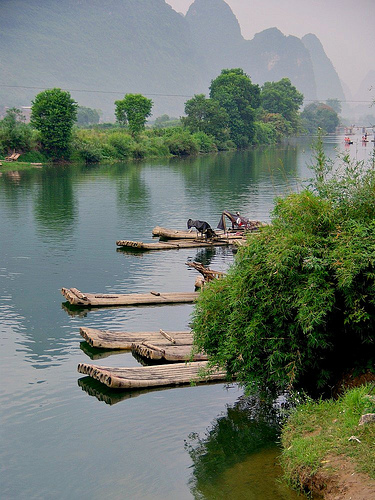<image>
Is there a seat on the boat? Yes. Looking at the image, I can see the seat is positioned on top of the boat, with the boat providing support. 